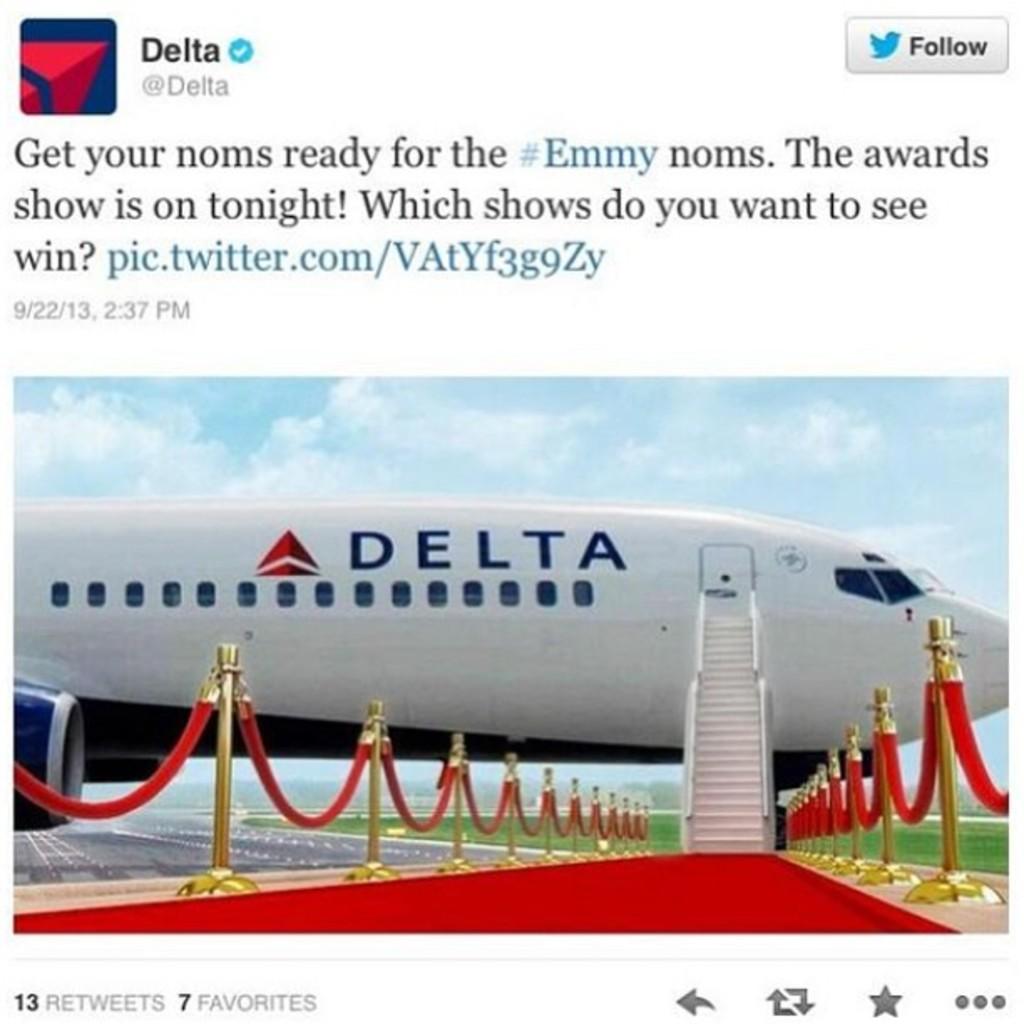Which airline does the plane belong to?
Keep it short and to the point. Delta. Is there people waiting to board the plane ?
Give a very brief answer. Answering does not require reading text in the image. 